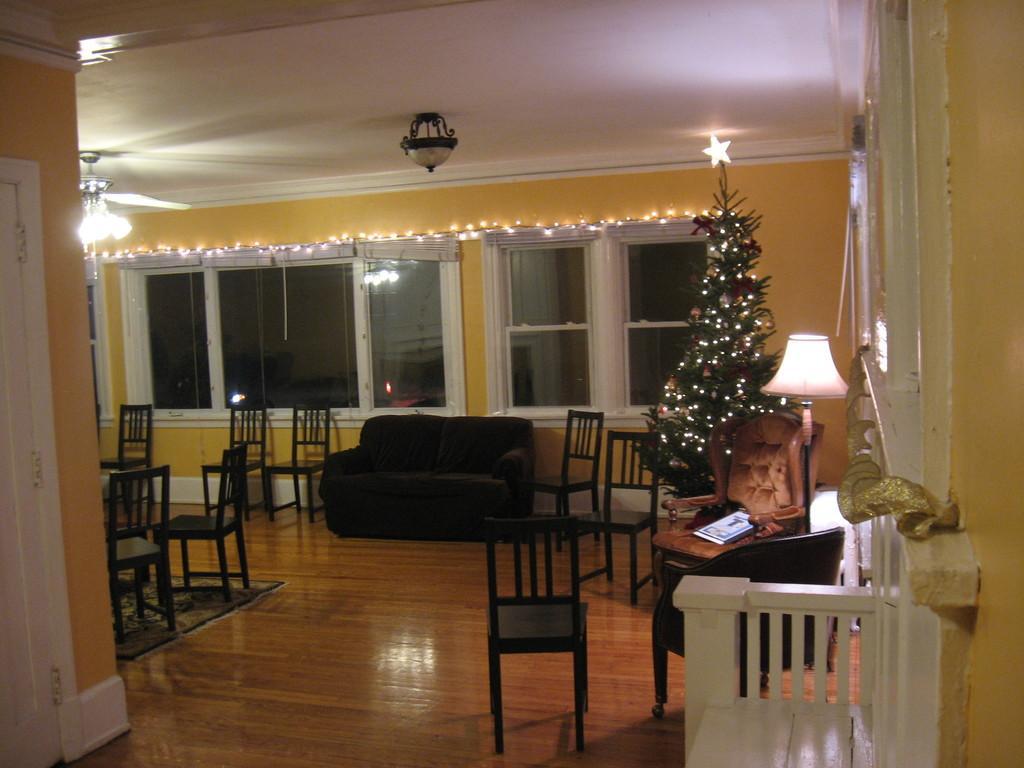Describe this image in one or two sentences. In this image I can see the few chairs,couch. To the right there is a Christmas tree and the lamp. In the background there is a window. 